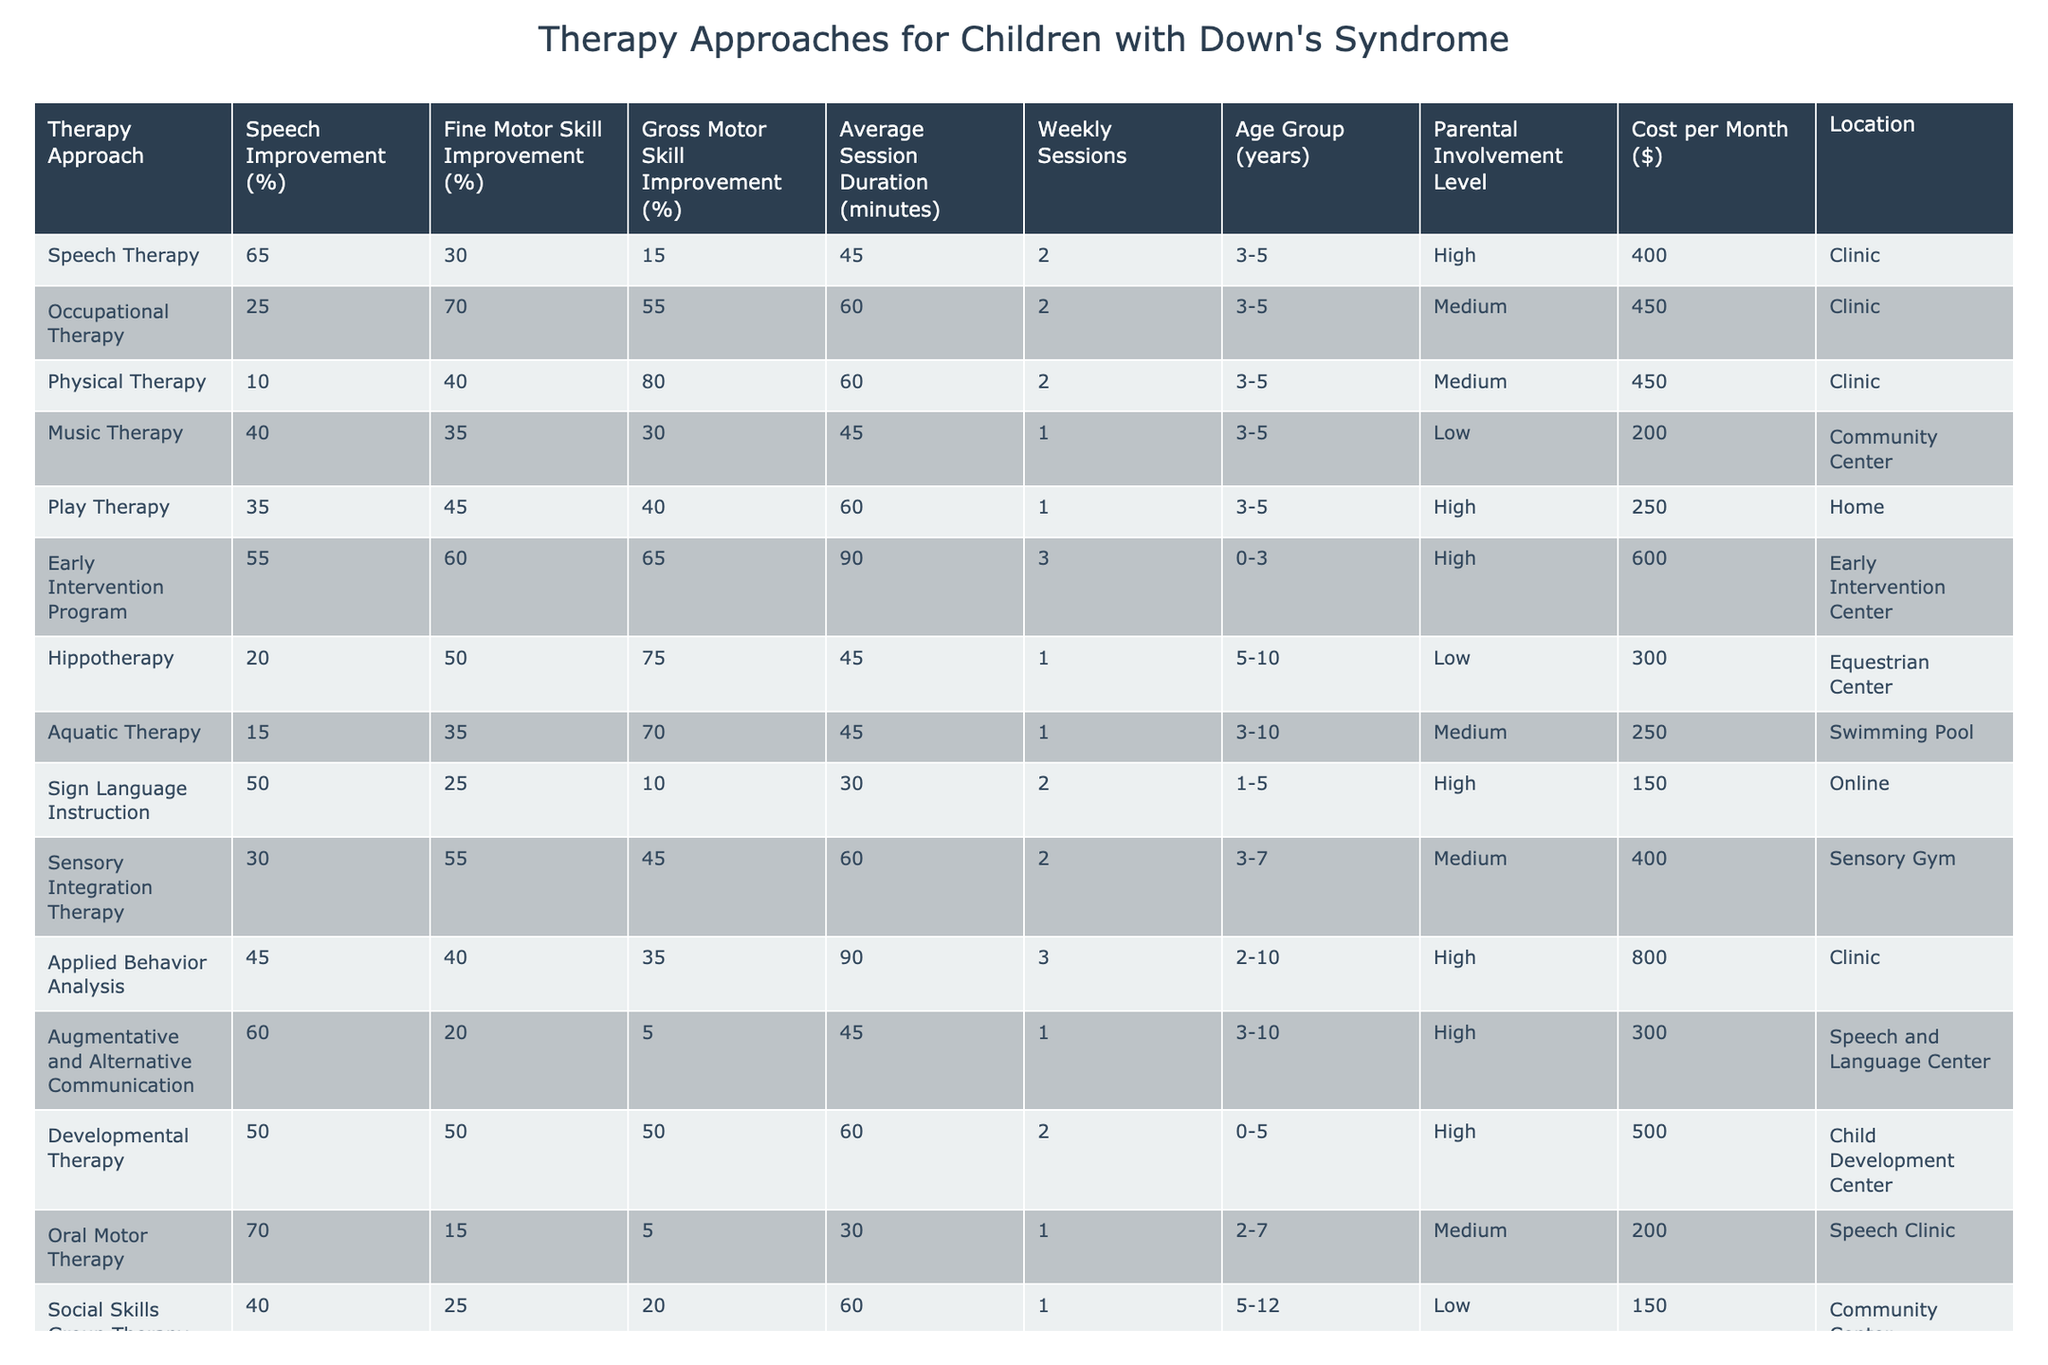What is the therapy approach with the highest speech improvement percentage? According to the table, Oral Motor Therapy has the highest speech improvement percentage at 70%.
Answer: 70% Which therapy approach has the lowest gross motor skill improvement percentage? The table indicates that Speech Therapy has the lowest gross motor skill improvement at 15%.
Answer: 15% How many weekly sessions does the Early Intervention Program require? The Early Intervention Program requires 3 weekly sessions, as stated in the table.
Answer: 3 What is the average cost per month of therapy approaches that have high parental involvement? The high parental involvement approaches are Speech Therapy, Play Therapy, Early Intervention Program, Sign Language Instruction, Sensory Integration Therapy, and Applied Behavior Analysis. Their costs are 400, 250, 600, 150, 400, and 800 respectively. The average cost is (400 + 250 + 600 + 150 + 400 + 800) / 6 = 425.
Answer: 425 Is there a therapy approach that offers both high speech improvement and high fine motor skill improvement? Yes, the Early Intervention Program offers high speech improvement (55%) and high fine motor skill improvement (60%).
Answer: Yes Which therapy has the longest average session duration? From the provided data, the Early Intervention Program has the longest average session duration of 90 minutes.
Answer: 90 minutes What is the percentage difference in fine motor skill improvement between Occupational Therapy and Play Therapy? Occupational Therapy has a fine motor skill improvement of 70%, while Play Therapy has 45%. The percentage difference is 70 - 45 = 25%.
Answer: 25% How many therapy approaches are located in a clinic? The table shows that there are 5 therapy approaches located in a clinic: Speech Therapy, Occupational Therapy, Physical Therapy, Applied Behavior Analysis, and Oral Motor Therapy.
Answer: 5 Which therapy approach is the most cost-effective based on the lowest cost per month? The therapy with the lowest cost per month is Sign Language Instruction at $150.
Answer: $150 Does Music Therapy require more weekly sessions than Aquatic Therapy? Music Therapy requires 1 weekly session, while Aquatic Therapy also requires 1 weekly session, so the answer is no, they are equal.
Answer: No 